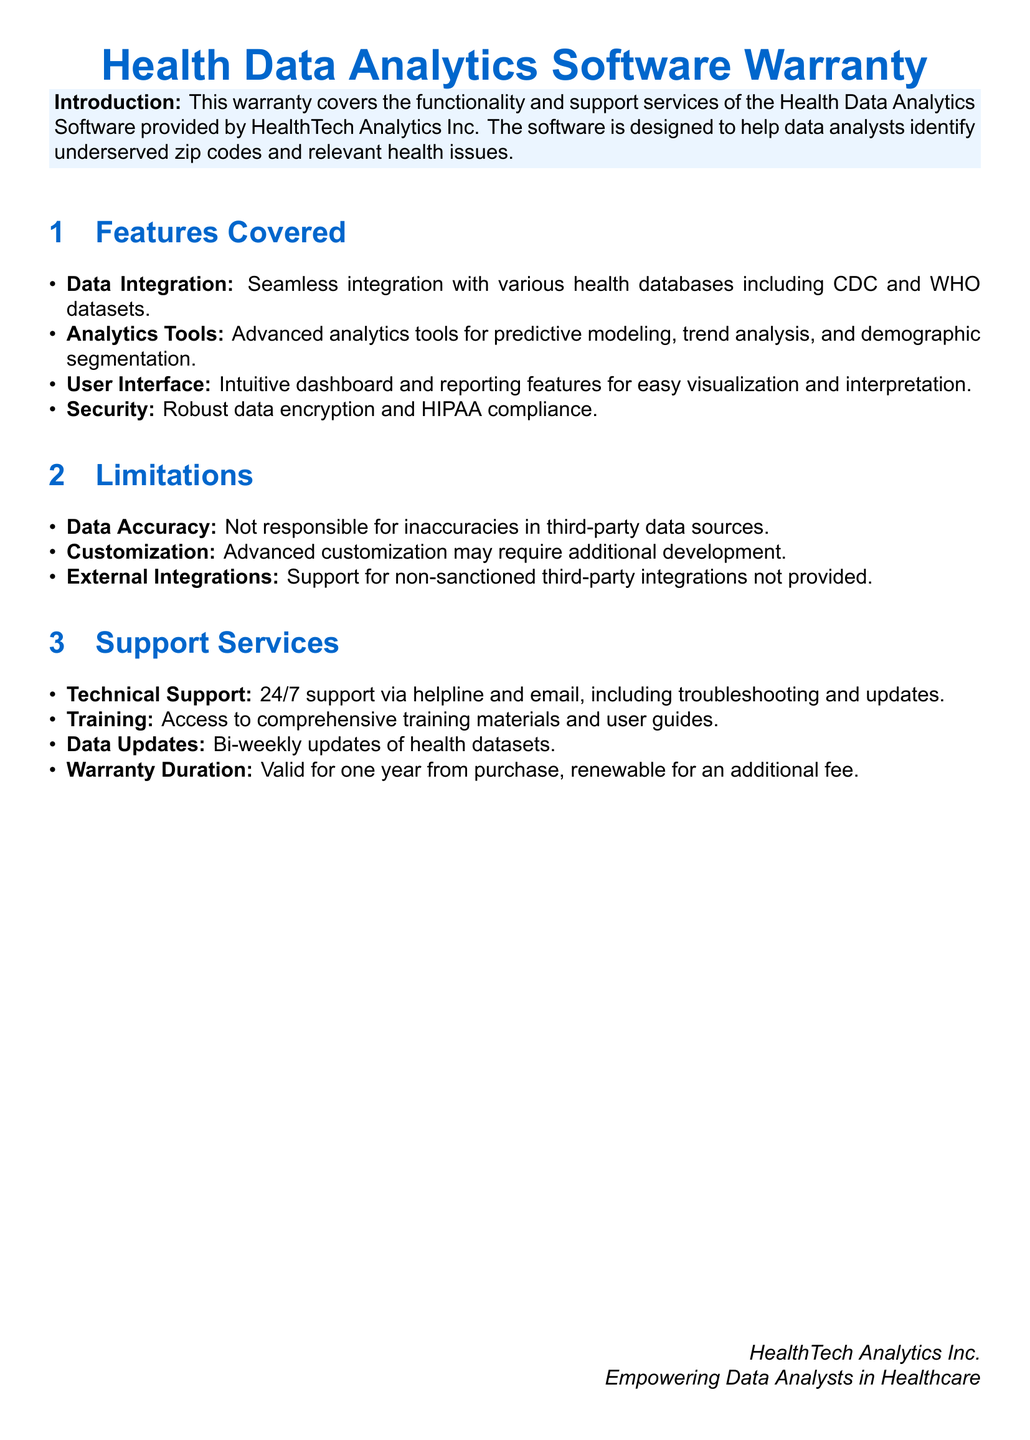What is the main purpose of the warranty? The warranty covers the functionality and support services of the Health Data Analytics Software designed to help data analysts identify underserved zip codes and relevant health issues.
Answer: Identifying underserved zip codes and relevant health issues How many features are listed under "Features Covered"? The document lists four features under the "Features Covered" section.
Answer: Four What type of support is available 24/7? The warranty includes 24/7 technical support via helpline and email.
Answer: Technical support What is the duration of the warranty? The warranty is valid for one year from purchase and is renewable for an additional fee.
Answer: One year What is the main limitation regarding data sources? The limitation states that the warranty is not responsible for inaccuracies in third-party data sources.
Answer: Inaccuracies in third-party data sources What feature ensures compliance with health regulations? The warranty mentions robust data encryption and HIPAA compliance as a key feature.
Answer: HIPAA compliance Which organization provides the Health Data Analytics Software? The software is provided by HealthTech Analytics Inc.
Answer: HealthTech Analytics Inc 